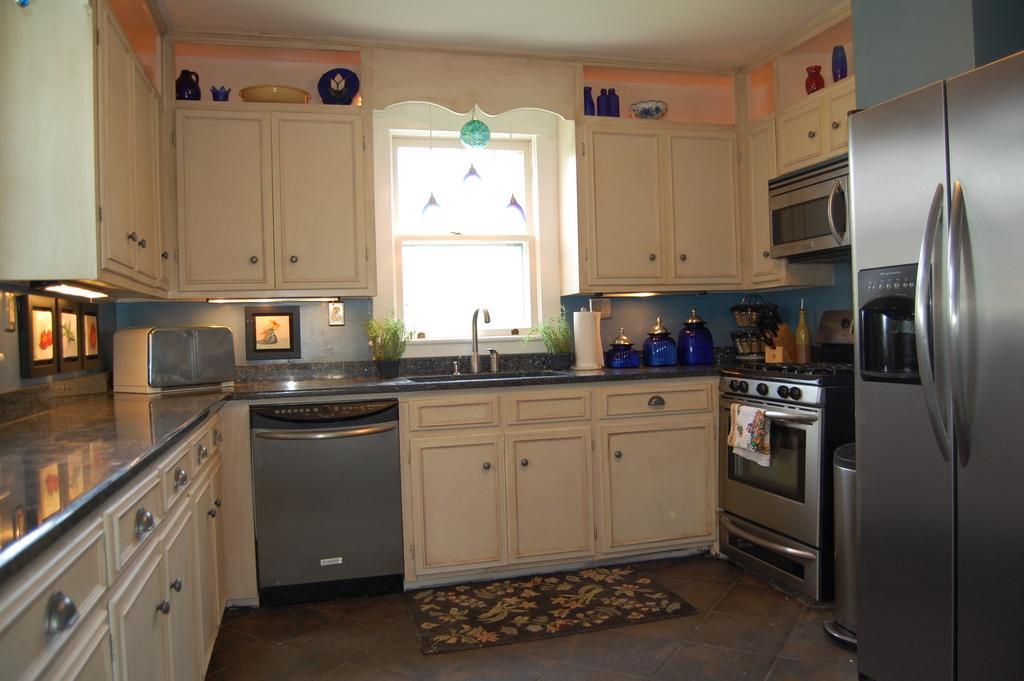In one or two sentences, can you explain what this image depicts? In this picture I can see the view of a kitchen and I see the counter top on which there are few things and I see the wash basin in the middle of this picture and behind it I see the window and on the wall I see the cupboards and on the left side of this image I see few more cupboards and I see a refrigerator on the right side of this image and beside to it I see an oven and I see the floor. 